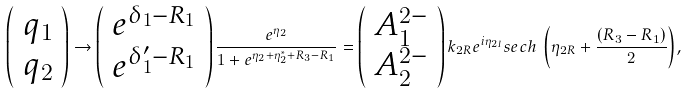Convert formula to latex. <formula><loc_0><loc_0><loc_500><loc_500>\left ( \begin{array} { c } q _ { 1 } \\ q _ { 2 } \end{array} \right ) \rightarrow \left ( \begin{array} { c } e ^ { \delta _ { 1 } - R _ { 1 } } \\ e ^ { \delta _ { 1 } ^ { \prime } - R _ { 1 } } \end{array} \right ) \frac { e ^ { \eta _ { 2 } } } { 1 + e ^ { \eta _ { 2 } + \eta _ { 2 } ^ { * } + R _ { 3 } - R _ { 1 } } } = \left ( \begin{array} { c } A _ { 1 } ^ { 2 - } \\ A _ { 2 } ^ { 2 - } \end{array} \right ) k _ { 2 R } e ^ { i \eta _ { 2 I } } { s e c h \, \left ( \eta _ { 2 R } + \frac { ( R _ { 3 } - R _ { 1 } ) } { 2 } \right ) } ,</formula> 